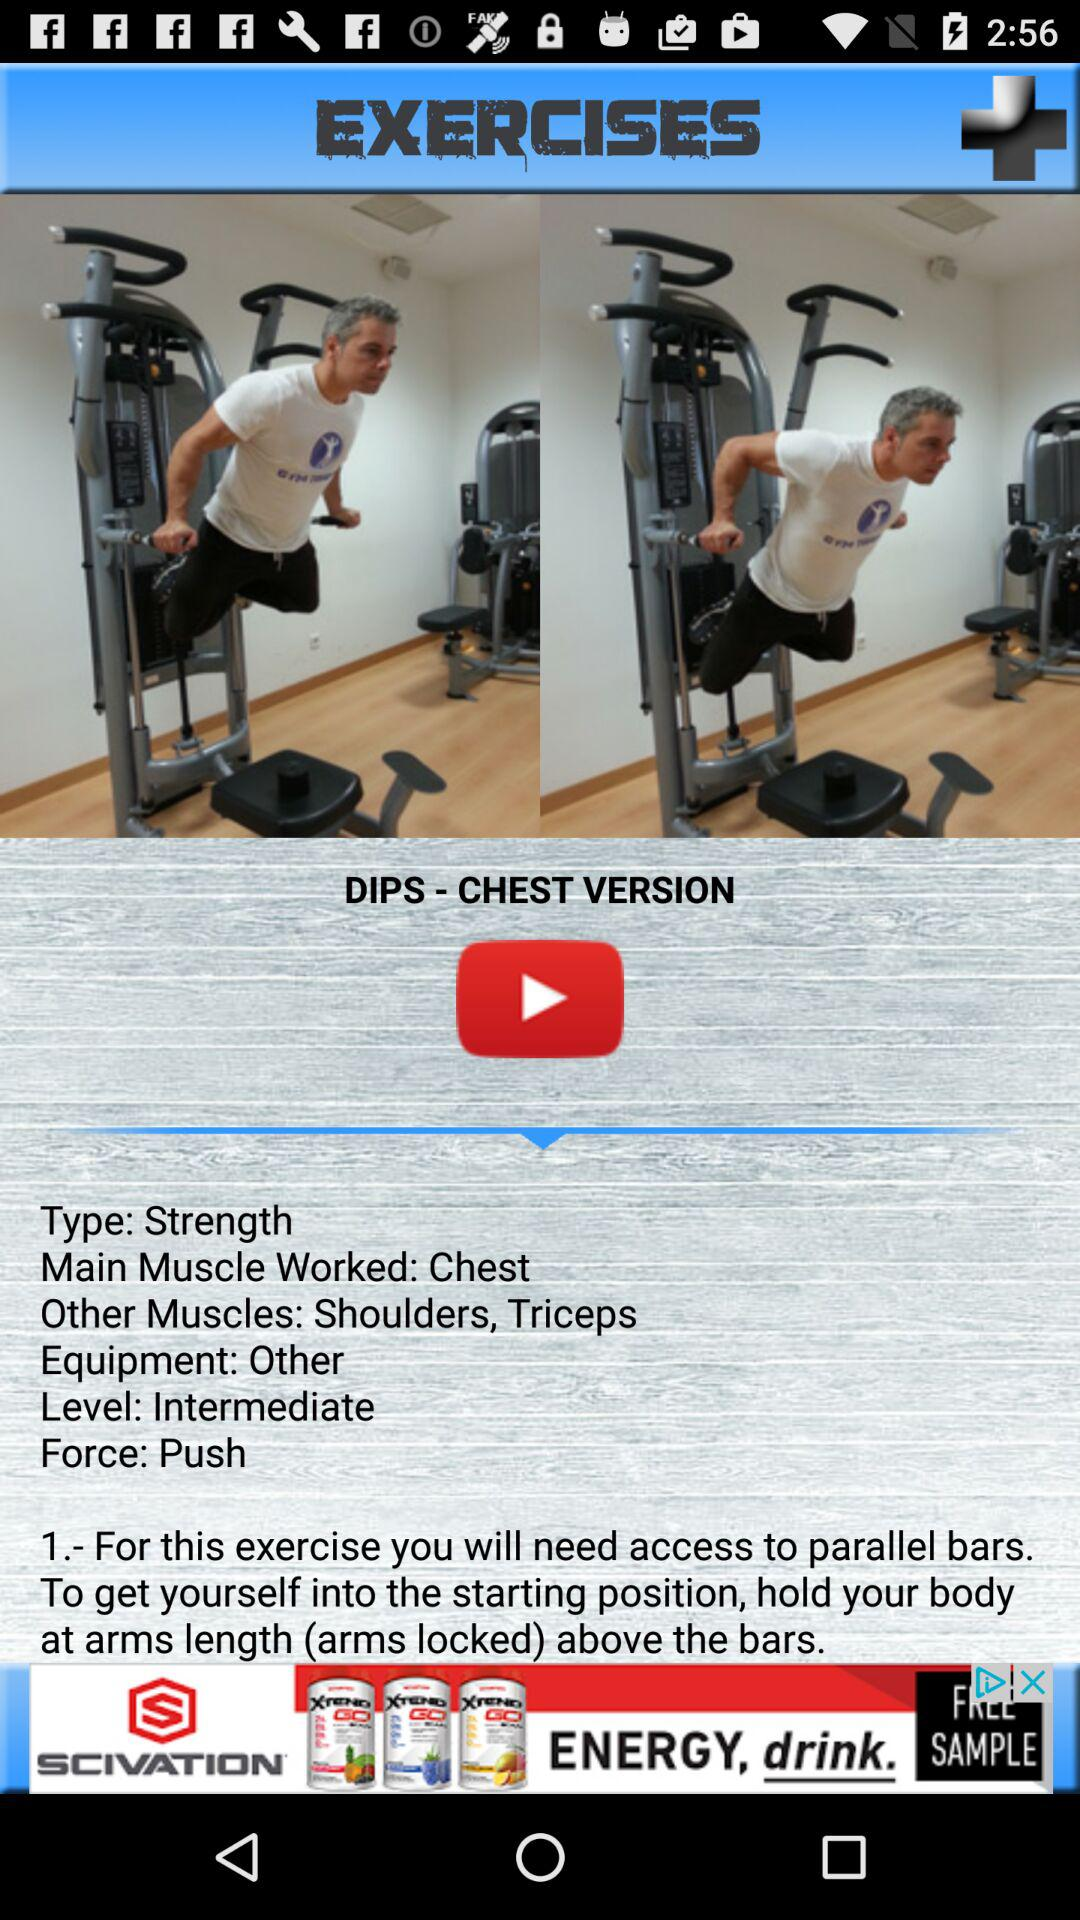What's the type of "DIPS - CHEST VERSION"? The type is "Strength". 